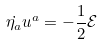Convert formula to latex. <formula><loc_0><loc_0><loc_500><loc_500>\dot { \eta _ { a } } u ^ { a } = - \frac { 1 } { 2 } { \mathcal { E } }</formula> 